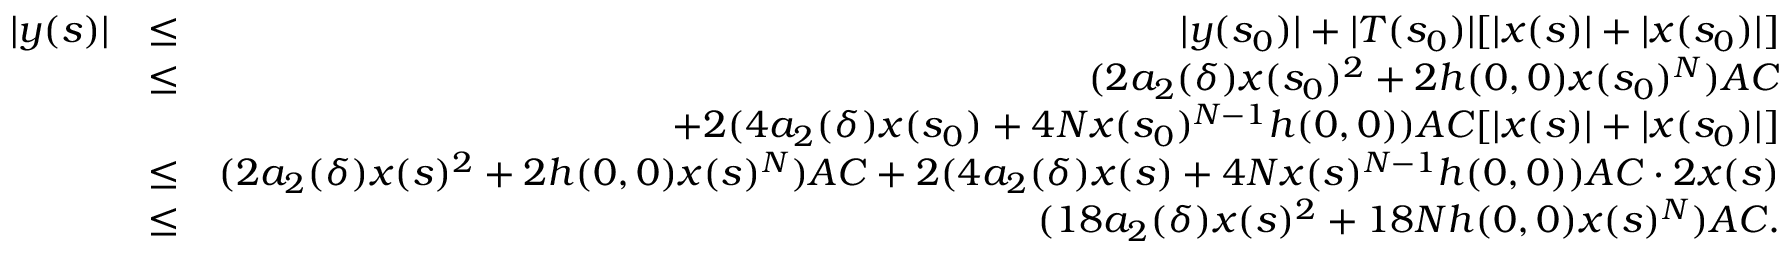Convert formula to latex. <formula><loc_0><loc_0><loc_500><loc_500>\begin{array} { r l r } { | y ( s ) | } & { \leq } & { | y ( s _ { 0 } ) | + | T ( s _ { 0 } ) | [ | x ( s ) | + | x ( s _ { 0 } ) | ] } \\ & { \leq } & { ( 2 a _ { 2 } ( \delta ) x ( s _ { 0 } ) ^ { 2 } + 2 h ( 0 , 0 ) x ( s _ { 0 } ) ^ { N } ) A C } \\ & { + 2 ( 4 a _ { 2 } ( \delta ) x ( s _ { 0 } ) + 4 N x ( s _ { 0 } ) ^ { N - 1 } h ( 0 , 0 ) ) A C [ | x ( s ) | + | x ( s _ { 0 } ) | ] } \\ & { \leq } & { ( 2 a _ { 2 } ( \delta ) x ( s ) ^ { 2 } + 2 h ( 0 , 0 ) x ( s ) ^ { N } ) A C + 2 ( 4 a _ { 2 } ( \delta ) x ( s ) + 4 N x ( s ) ^ { N - 1 } h ( 0 , 0 ) ) A C \cdot 2 x ( s ) } \\ & { \leq } & { ( 1 8 a _ { 2 } ( \delta ) x ( s ) ^ { 2 } + 1 8 N h ( 0 , 0 ) x ( s ) ^ { N } ) A C . } \end{array}</formula> 